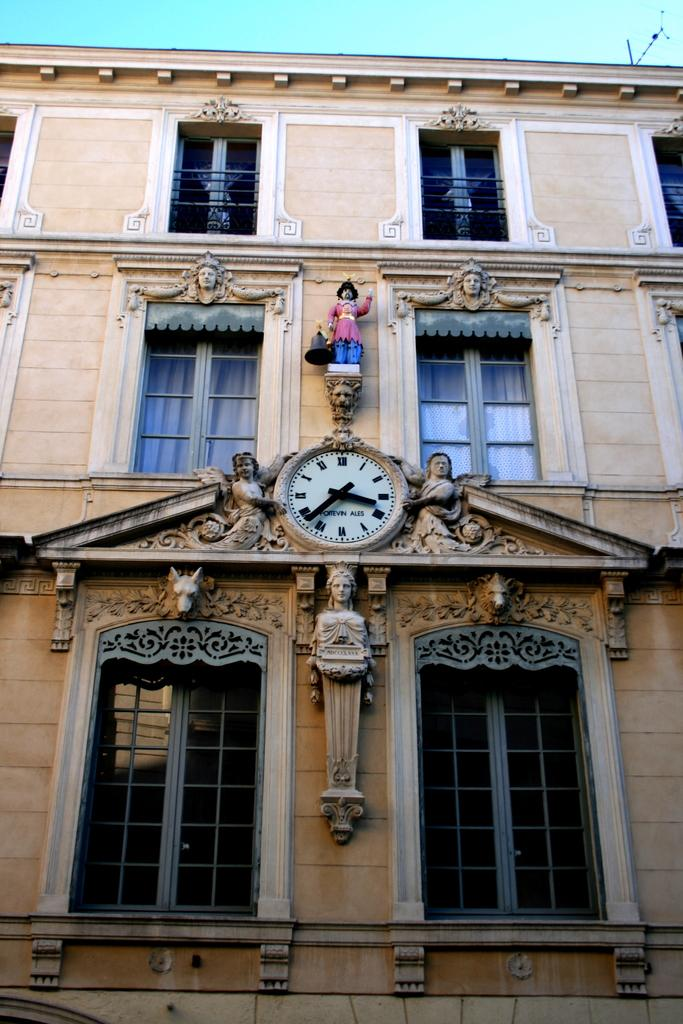<image>
Relay a brief, clear account of the picture shown. A large clock on top of a building says the time is 4:36 